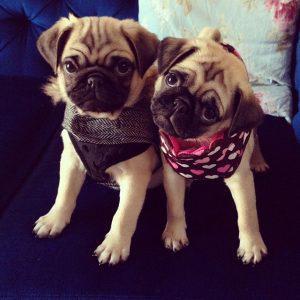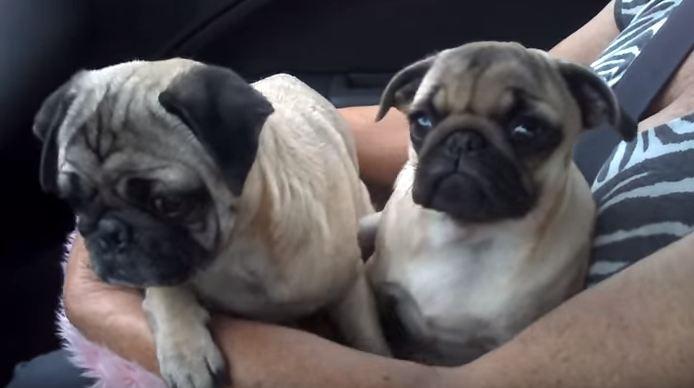The first image is the image on the left, the second image is the image on the right. Assess this claim about the two images: "At least one of the dogs is wearing something around its neck.". Correct or not? Answer yes or no. Yes. The first image is the image on the left, the second image is the image on the right. Given the left and right images, does the statement "The majority of dogs pictured are black, and one image contains only black-colored pugs." hold true? Answer yes or no. No. 